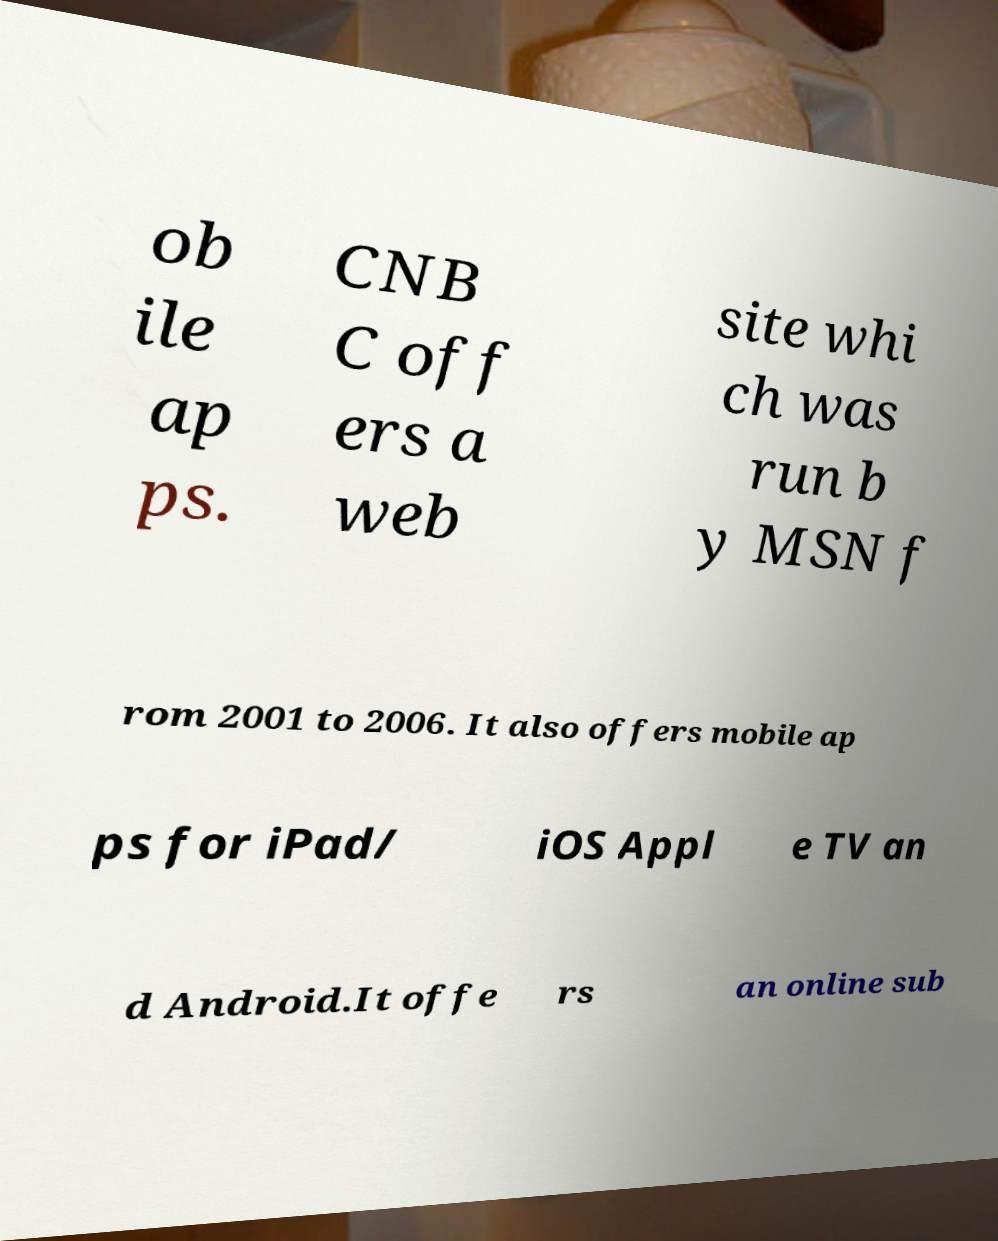Please identify and transcribe the text found in this image. ob ile ap ps. CNB C off ers a web site whi ch was run b y MSN f rom 2001 to 2006. It also offers mobile ap ps for iPad/ iOS Appl e TV an d Android.It offe rs an online sub 